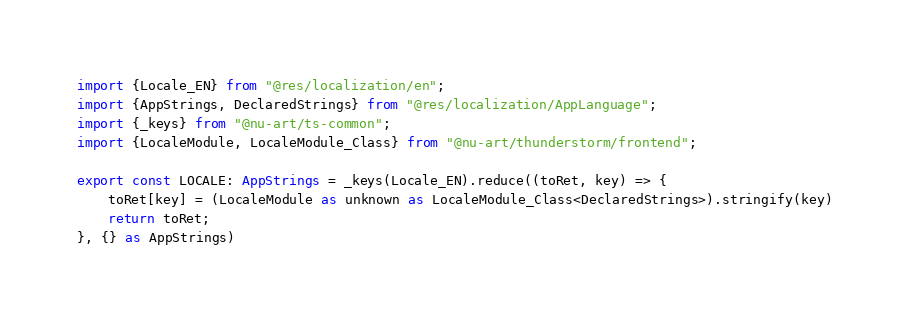Convert code to text. <code><loc_0><loc_0><loc_500><loc_500><_TypeScript_>import {Locale_EN} from "@res/localization/en";
import {AppStrings, DeclaredStrings} from "@res/localization/AppLanguage";
import {_keys} from "@nu-art/ts-common";
import {LocaleModule, LocaleModule_Class} from "@nu-art/thunderstorm/frontend";

export const LOCALE: AppStrings = _keys(Locale_EN).reduce((toRet, key) => {
	toRet[key] = (LocaleModule as unknown as LocaleModule_Class<DeclaredStrings>).stringify(key)
	return toRet;
}, {} as AppStrings)
</code> 